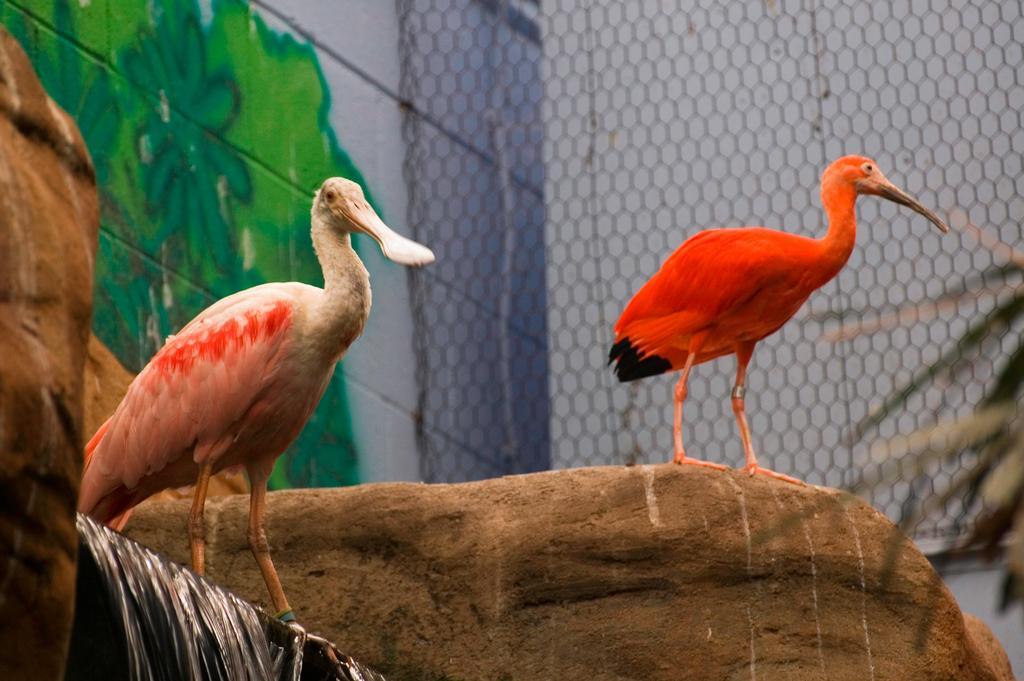Could you give a brief overview of what you see in this image? In this image, in the middle there are two birds. At the bottom there are stones, waterfall. In the background there is a net, wall, wall paint. 